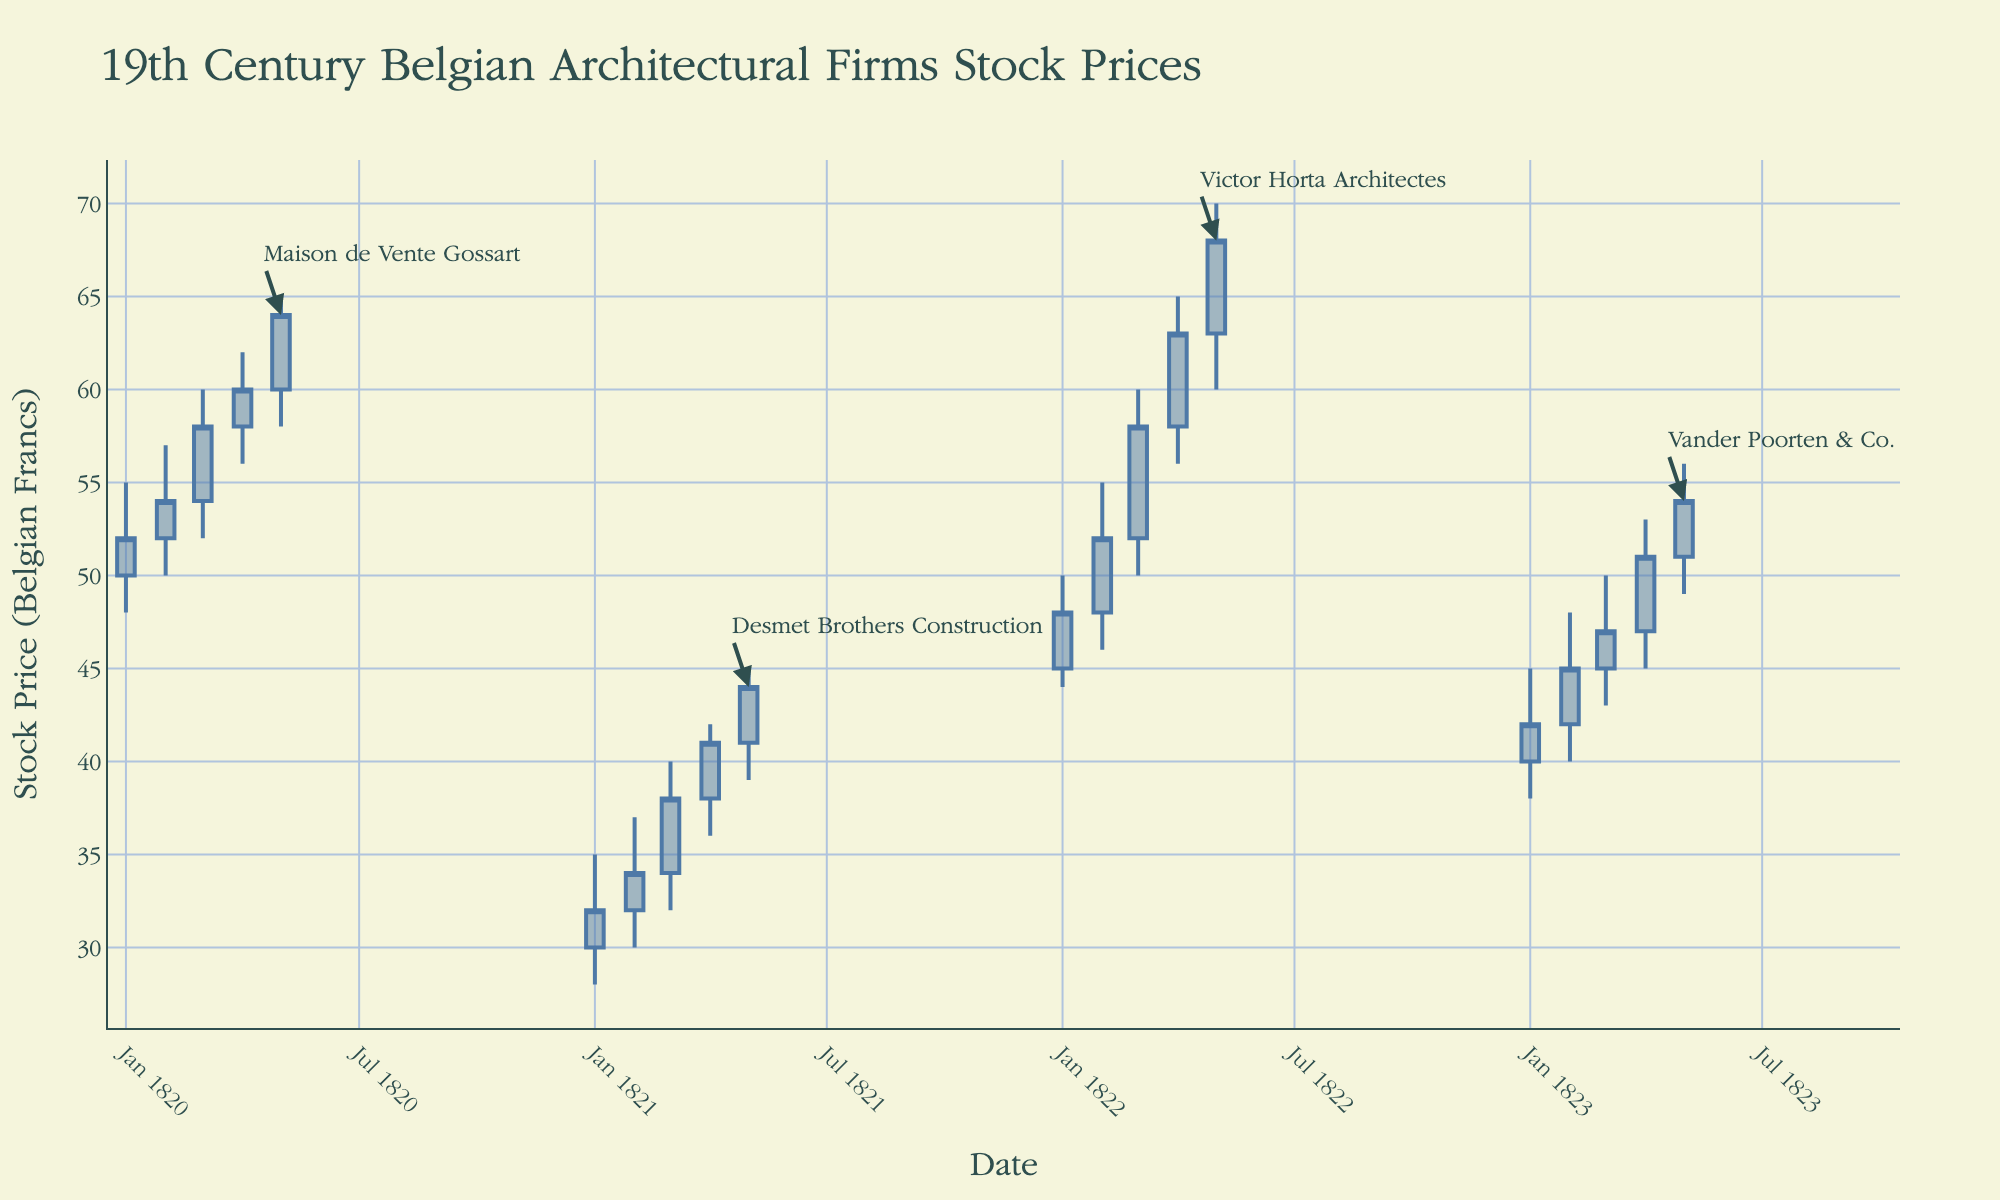What is the title of the candlestick chart? The title of the chart is centrally located at the top of the figure and typically written in a larger font size.
Answer: 19th Century Belgian Architectural Firms Stock Prices What is the highest stock price reached by Maison de Vente Gossart? Look at the candlestick representing Maison de Vente Gossart and find the highest point on the y-axis.
Answer: 65 Belgian Francs On what date did Desmet Brothers Construction reach its peak closing price? Observe the closing ends of candlesticks corresponding to Desmet Brothers Construction and identify the highest one on the x-axis.
Answer: 1821-05-01 How does the stock price trend of Victor Horta Architectes compare from January 1822 to May 1822? Track the candlesticks for Victor Horta Architectes from January to May 1822 and describe the trend by checking the variations in opening and closing prices.
Answer: It rose steadily What was the stock price range (difference between the highest and lowest prices) for Vander Poorten & Co. in April 1823? Identify the candlestick for April 1823 and compute the difference between the highest and lowest points on the y-axis for Vander Poorten & Co.
Answer: 8 Belgian Francs Which company showed the greatest percentage increase in stock price from its initial value to the final value in the given data? Identify the initial and final closing prices for each company, compute their percentage increases, and compare them.
Answer: Victor Horta Architectes What was the average closing price of Desmet Brothers Construction from January to May 1821? Add the closing prices of Desmet Brothers Construction from January to May 1821 and divide by the number of months (5).
Answer: 37.8 Belgian Francs Compared to the initial stock price, how much did the closing price of Maison de Vente Gossart increase by May 1820? Subtract the initial closing price from the final closing price for Maison de Vente Gossart.
Answer: 12 Belgian Francs Which month in 1820 saw the largest increase in stock price for Maison de Vente Gossart? Look at the candlesticks for each month in 1820 and identify the month with the largest vertical length showing the biggest price difference.
Answer: March 1820 Did any company’s stock price close below 30 Belgian Francs during the given period? Identify the closing prices for each company and see if any fall below 30 Belgian Francs.
Answer: No 